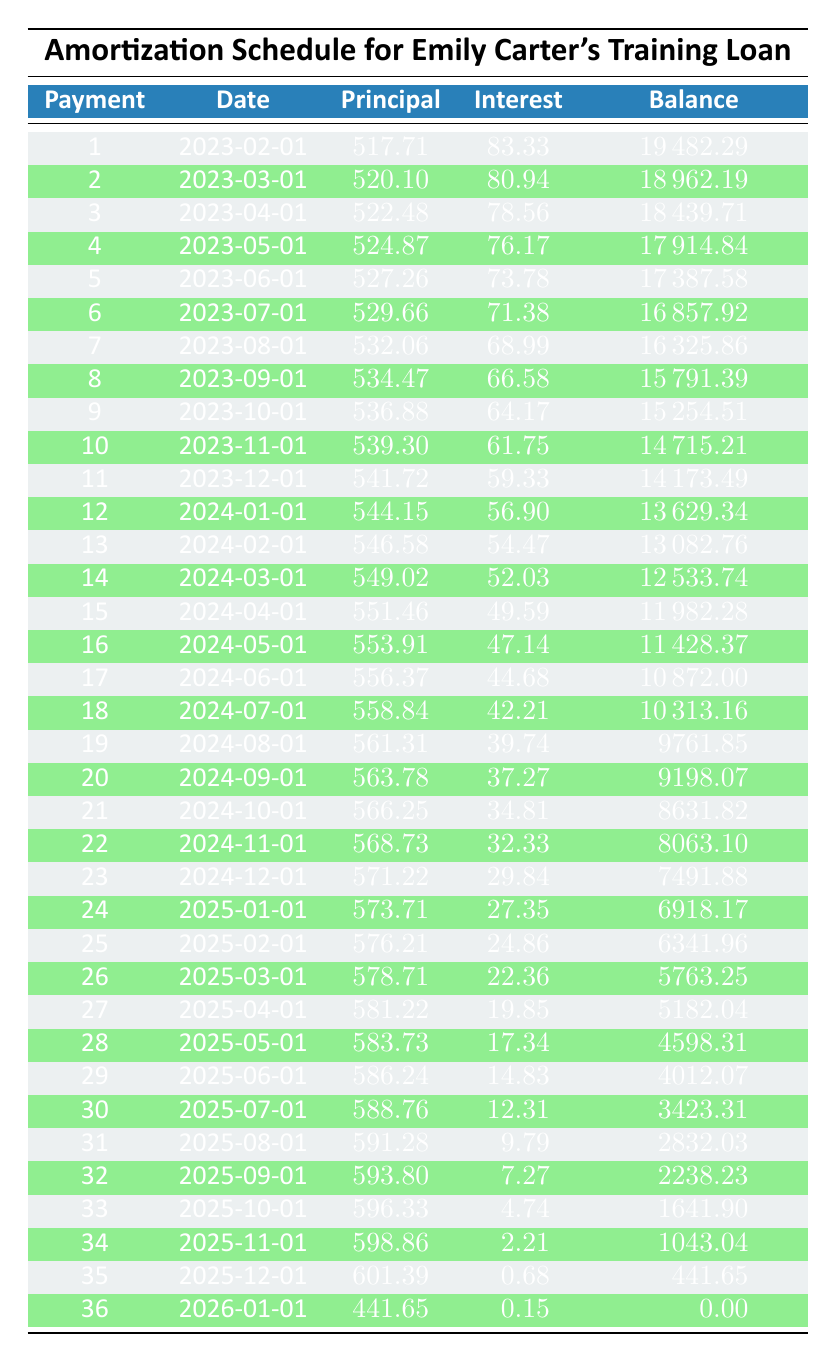What is the total amount of interest Emily Carter pays over the entire loan term? To find the total interest paid, we need to sum the interest payments from each month across the entire term. Adding all interest payments together (83.33 + 80.94 + 78.56 + ... + 0.15) gives a total interest of 465.44.
Answer: 465.44 What is the remaining balance after the first payment? The remaining balance after the first payment can be found directly in the table under the row that corresponds to the first payment. It shows 19482.29.
Answer: 19482.29 How much principal is paid in the 10th payment? Referring to the 10th payment row in the table, the principal payment is listed as 539.30.
Answer: 539.30 Is the interest payment for the 15th payment greater than the interest payment for the 20th payment? By checking the interest payments for both the 15th and 20th payments in the table, we see that 49.59 (15th) is greater than 37.27 (20th). Therefore, the statement is true.
Answer: Yes What is the average principal payment made during the first 3 months? The principal payments for the first three months are 517.71, 520.10, and 522.48. To calculate the average, we first find the sum: 517.71 + 520.10 + 522.48 = 1560.29, then divide by 3 which is 1560.29/3 = 520.10.
Answer: 520.10 How many payments are made after the balance falls below 5000? The balance falls below 5000 after the 27th payment, which means that from the 28th to the 36th payment (inclusive) will be made after the balance is less than 5000. Counting these gives a total of 9 payments.
Answer: 9 What is the total remaining balance at the end of the loan term? At the end of the loan term, the remaining balance is stated in the last entry of the table. It shows a remaining balance of 0.00 after the final payment.
Answer: 0.00 Is Emily's training loan interest rate lower than 6%? The interest rate for the loan is explicitly stated in the loan details as 5%, which is lower than 6%. Therefore, the answer is true.
Answer: Yes 